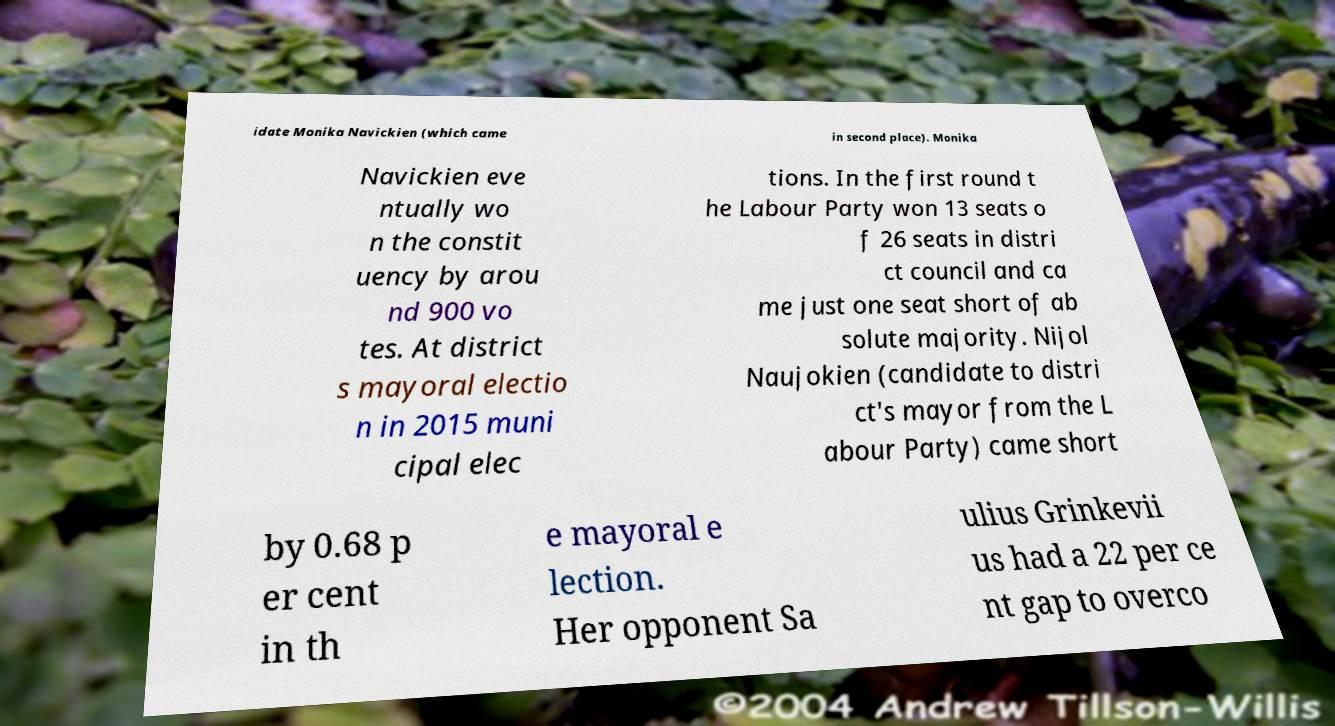I need the written content from this picture converted into text. Can you do that? idate Monika Navickien (which came in second place). Monika Navickien eve ntually wo n the constit uency by arou nd 900 vo tes. At district s mayoral electio n in 2015 muni cipal elec tions. In the first round t he Labour Party won 13 seats o f 26 seats in distri ct council and ca me just one seat short of ab solute majority. Nijol Naujokien (candidate to distri ct's mayor from the L abour Party) came short by 0.68 p er cent in th e mayoral e lection. Her opponent Sa ulius Grinkevii us had a 22 per ce nt gap to overco 